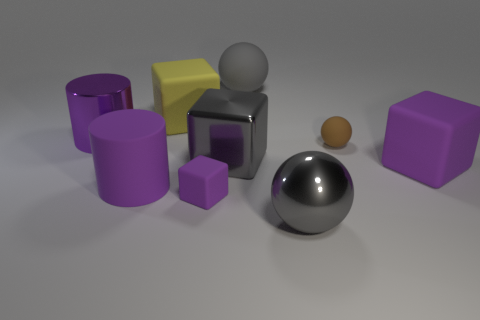Subtract all yellow cubes. How many cubes are left? 3 Subtract all big gray metal cubes. How many cubes are left? 3 Subtract all brown cubes. Subtract all yellow balls. How many cubes are left? 4 Subtract all cylinders. How many objects are left? 7 Add 7 purple rubber cubes. How many purple rubber cubes exist? 9 Subtract 0 green spheres. How many objects are left? 9 Subtract all big metallic cylinders. Subtract all small brown balls. How many objects are left? 7 Add 1 tiny purple objects. How many tiny purple objects are left? 2 